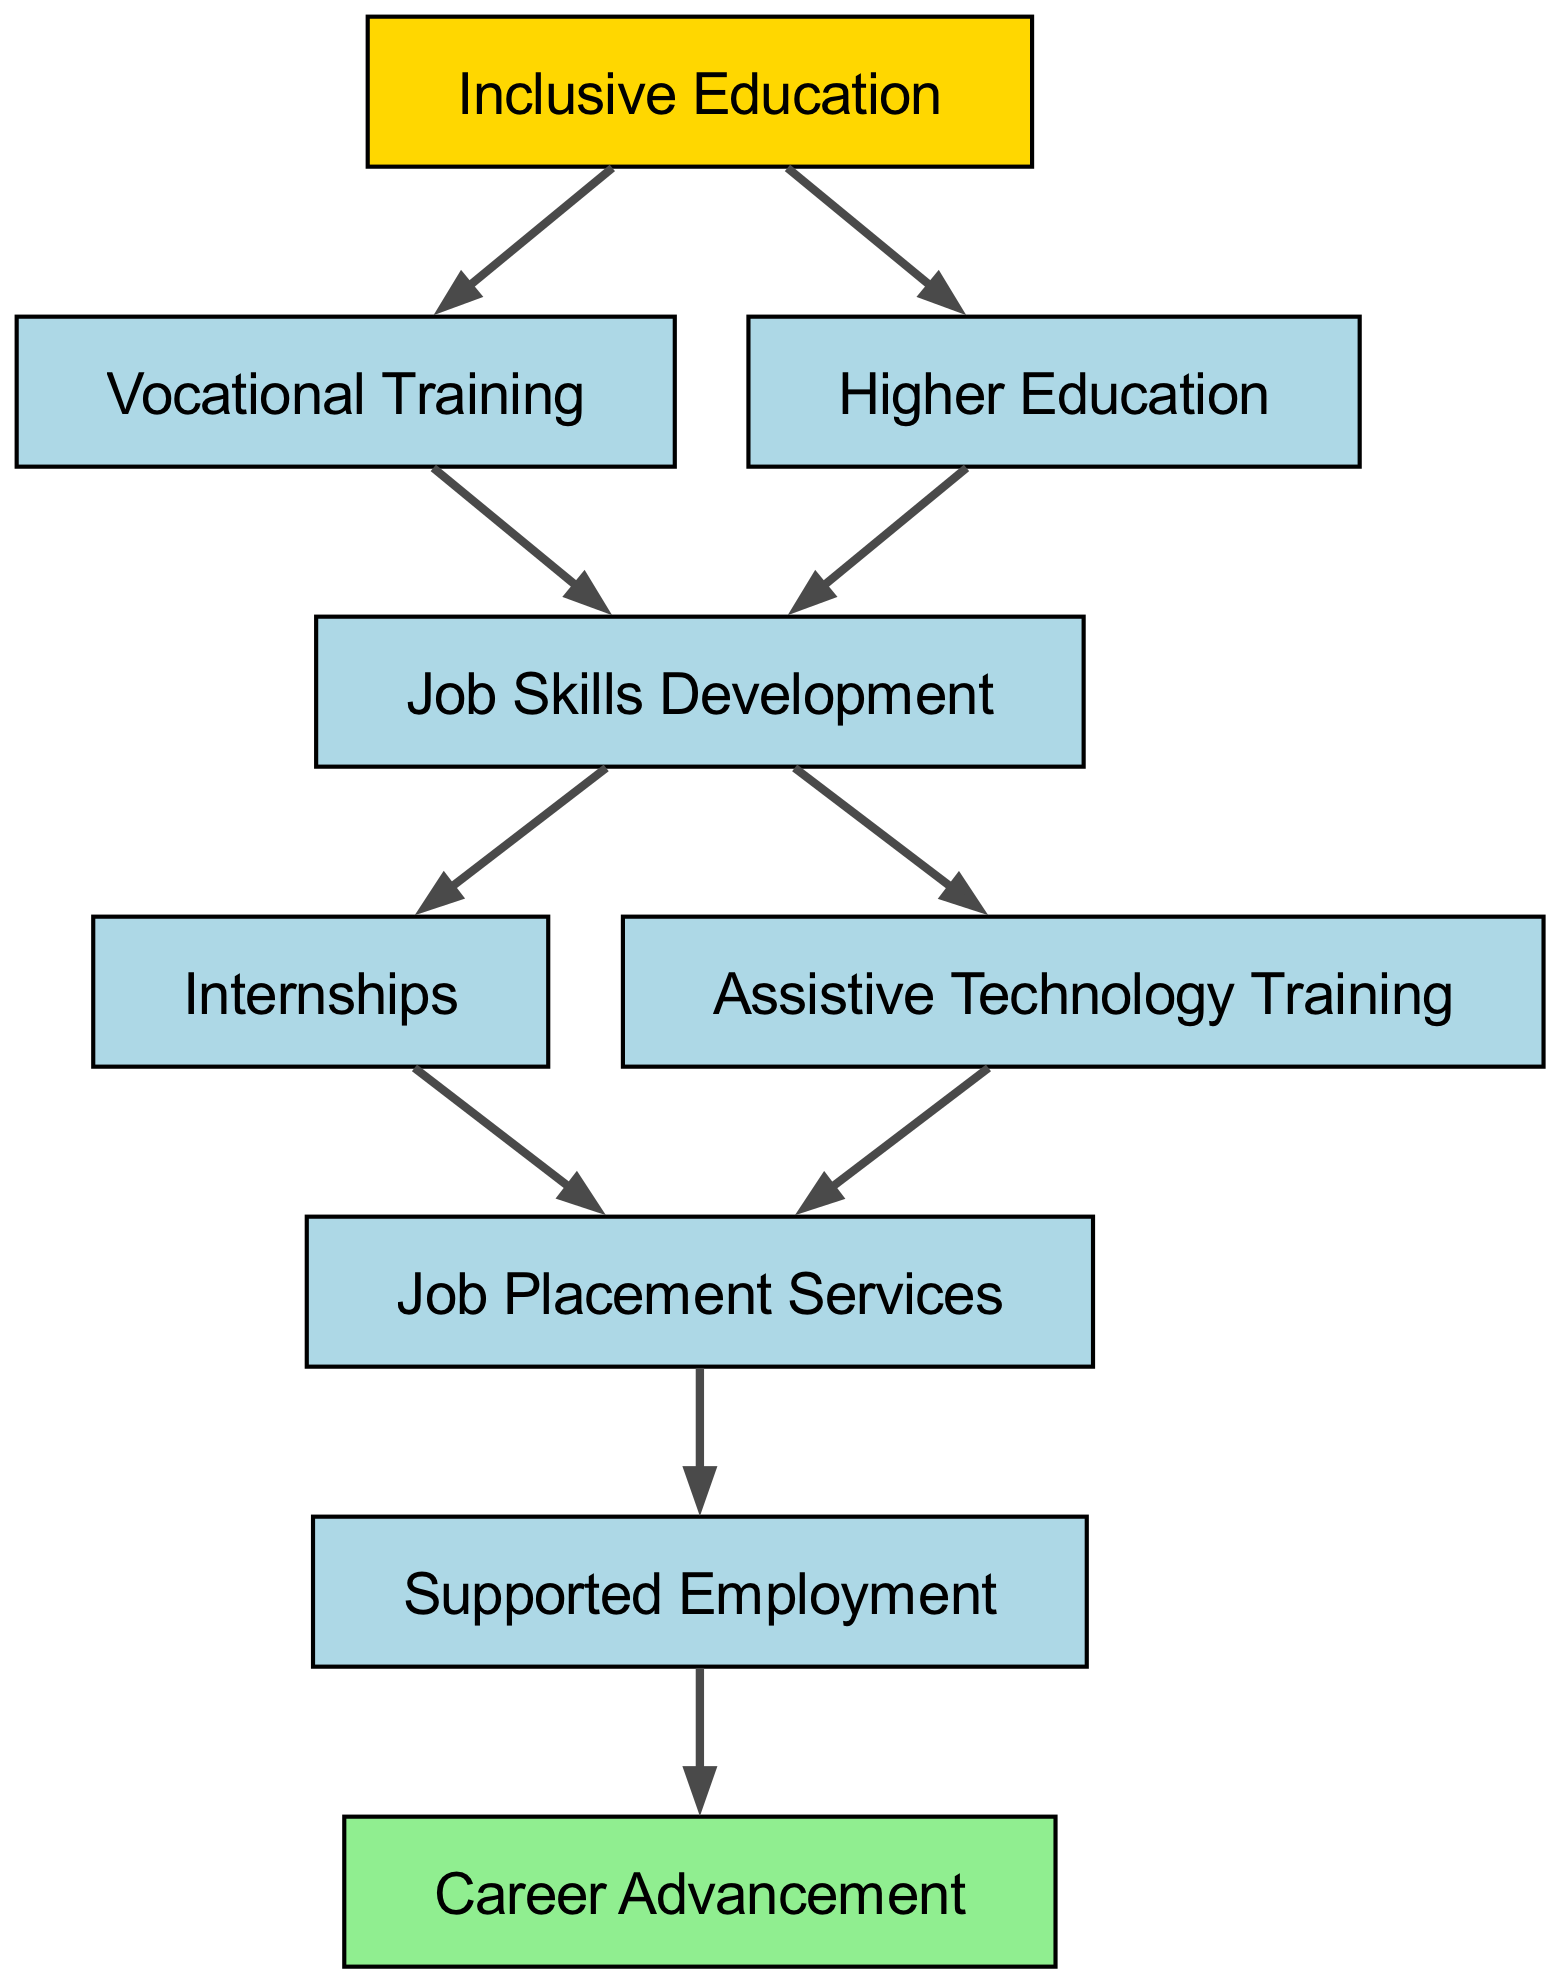What is the starting point of the career development path? The diagram indicates that the starting point of the career development path is "Inclusive Education." This is supported by the connection from node "1" to its subsequent nodes.
Answer: Inclusive Education How many nodes are there in total? By counting all the elements in the diagram, including the starting and ending nodes, there are a total of nine nodes connected through various paths.
Answer: Nine What connects "Vocational Training" to "Job Skills Development"? The connection is direct, as indicated in the diagram where "Vocational Training" (node "2") leads to "Job Skills Development" (node "4"). This shows a flow of development from education to skills needed for jobs.
Answer: Job Skills Development Which node follows "Internships" in the path? According to the diagram, "Internships" (node "5") leads directly to "Job Placement Services" (node "7"). This represents a sequential step where practical work experience progresses to finding job opportunities.
Answer: Job Placement Services What is the final step in the career development path? The last node in the diagram represents the final outcome of the career development process, which is "Career Advancement." This shows the ultimate goal within the progression of the pathway.
Answer: Career Advancement What two nodes lead to "Job Skills Development"? The diagram shows two distinct paths leading to "Job Skills Development"; these paths come from "Vocational Training" (node "2") and "Higher Education" (node "3"). This illustrates multiple educational routes leading to skill development.
Answer: Vocational Training and Higher Education How many connections does "Job Placement Services" have? In the diagram, "Job Placement Services" (node "7") connects to one following node, which is "Supported Employment" (node "8"). Therefore, it has one outgoing connection directly leading to the next step in the path.
Answer: One What does "Assistive Technology Training" connect to? From the diagram, "Assistive Technology Training" (node "6") leads directly to "Job Placement Services" (node "7"). This indicates that training in assistive technology is a precursor to utilizing job placement resources.
Answer: Job Placement Services What role do "Internships" have in the career development path? "Internships" (node "5") play a significant role as they link directly to "Job Placement Services" (node "7"), indicating that they provide practical experience that can lead to finding employment opportunities.
Answer: Job Placement Services 